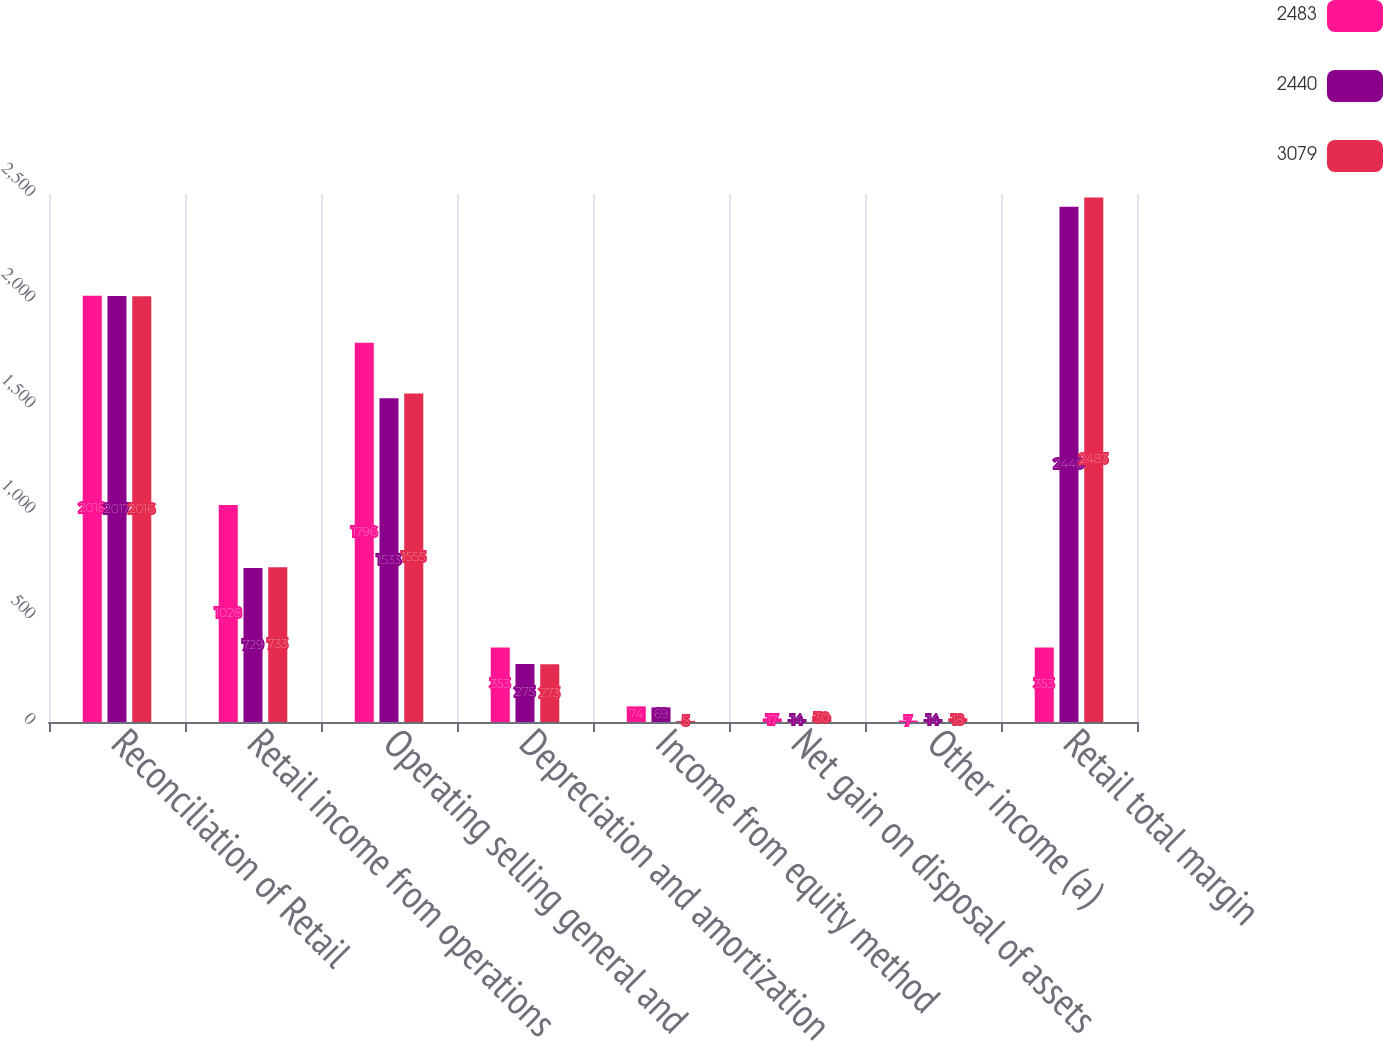<chart> <loc_0><loc_0><loc_500><loc_500><stacked_bar_chart><ecel><fcel>Reconciliation of Retail<fcel>Retail income from operations<fcel>Operating selling general and<fcel>Depreciation and amortization<fcel>Income from equity method<fcel>Net gain on disposal of assets<fcel>Other income (a)<fcel>Retail total margin<nl><fcel>2483<fcel>2018<fcel>1028<fcel>1796<fcel>353<fcel>74<fcel>17<fcel>7<fcel>353<nl><fcel>2440<fcel>2017<fcel>729<fcel>1533<fcel>275<fcel>69<fcel>14<fcel>14<fcel>2440<nl><fcel>3079<fcel>2016<fcel>733<fcel>1555<fcel>273<fcel>5<fcel>30<fcel>18<fcel>2483<nl></chart> 